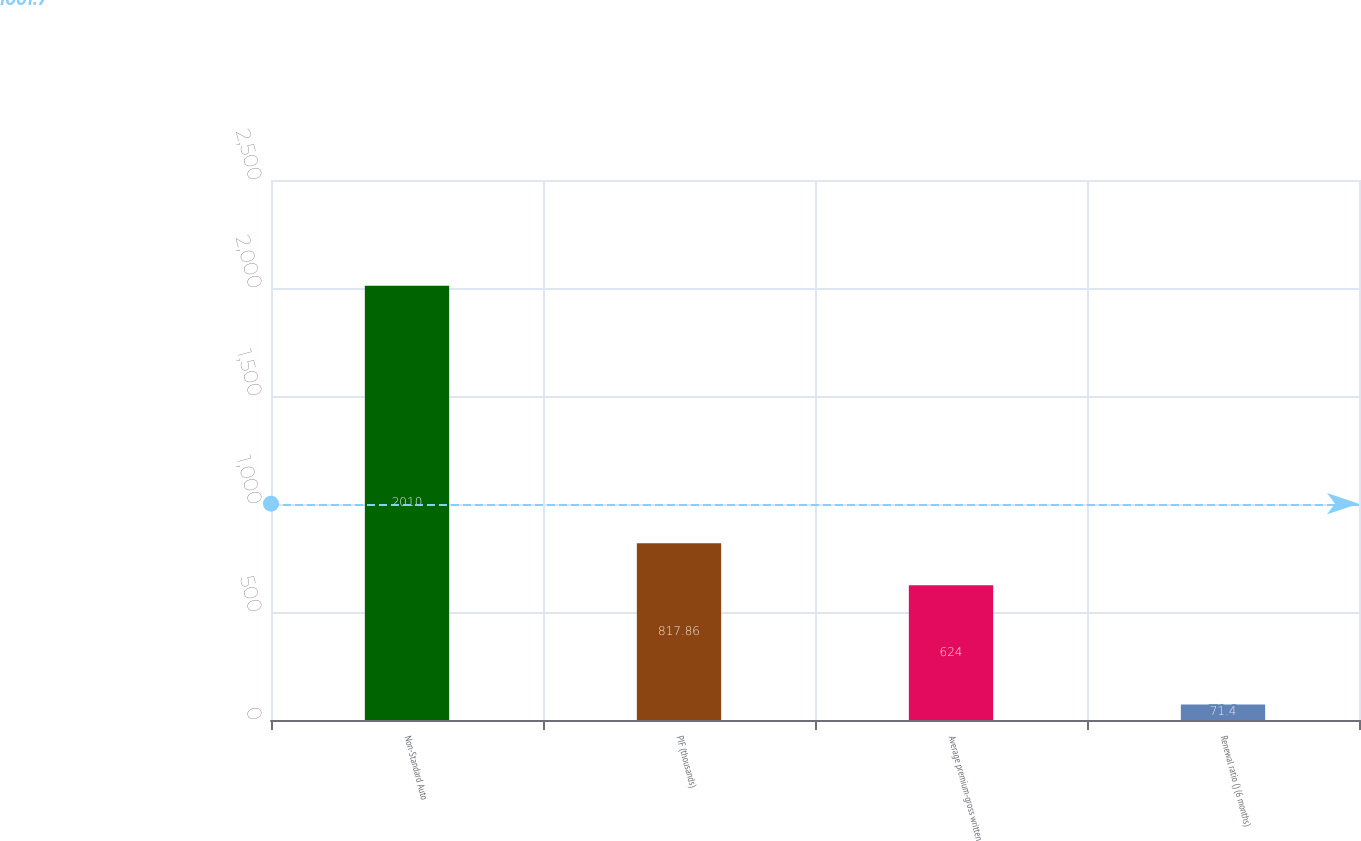Convert chart. <chart><loc_0><loc_0><loc_500><loc_500><bar_chart><fcel>Non-Standard Auto<fcel>PIF (thousands)<fcel>Average premium-gross written<fcel>Renewal ratio () (6 months)<nl><fcel>2010<fcel>817.86<fcel>624<fcel>71.4<nl></chart> 